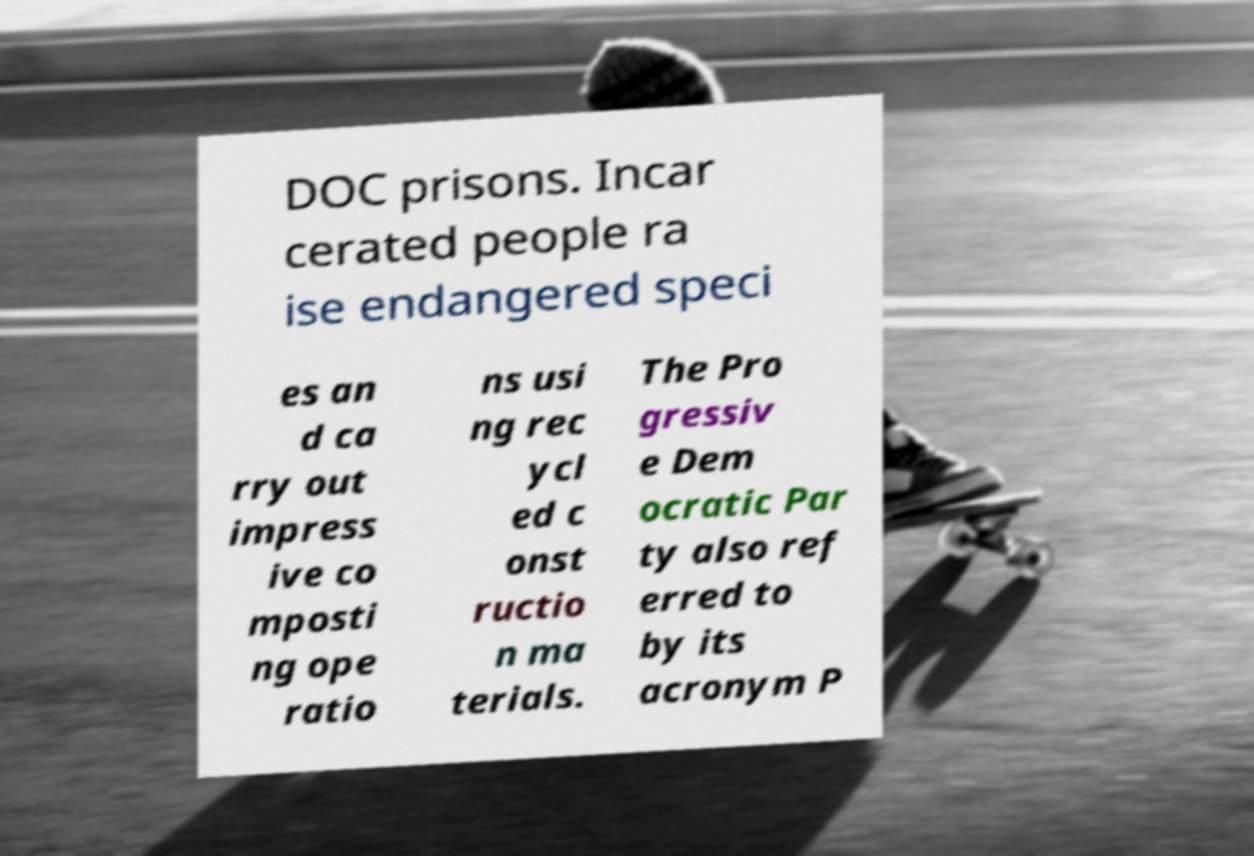What messages or text are displayed in this image? I need them in a readable, typed format. DOC prisons. Incar cerated people ra ise endangered speci es an d ca rry out impress ive co mposti ng ope ratio ns usi ng rec ycl ed c onst ructio n ma terials. The Pro gressiv e Dem ocratic Par ty also ref erred to by its acronym P 